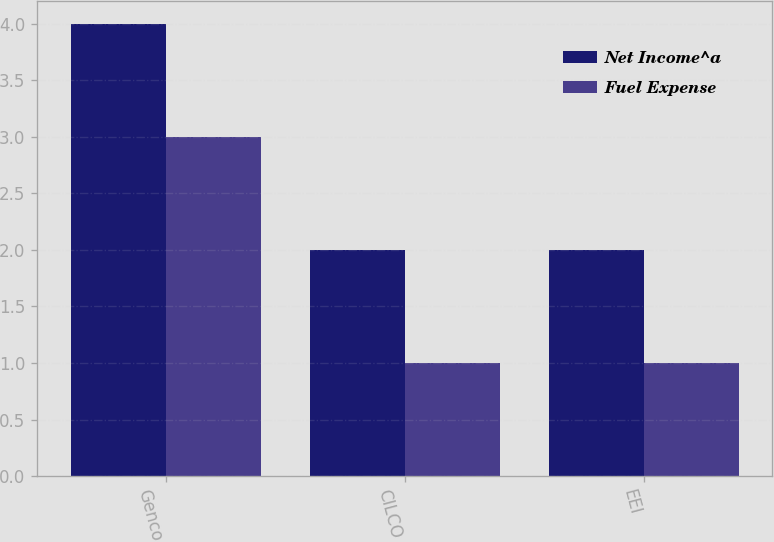<chart> <loc_0><loc_0><loc_500><loc_500><stacked_bar_chart><ecel><fcel>Genco<fcel>CILCO<fcel>EEI<nl><fcel>Net Income^a<fcel>4<fcel>2<fcel>2<nl><fcel>Fuel Expense<fcel>3<fcel>1<fcel>1<nl></chart> 